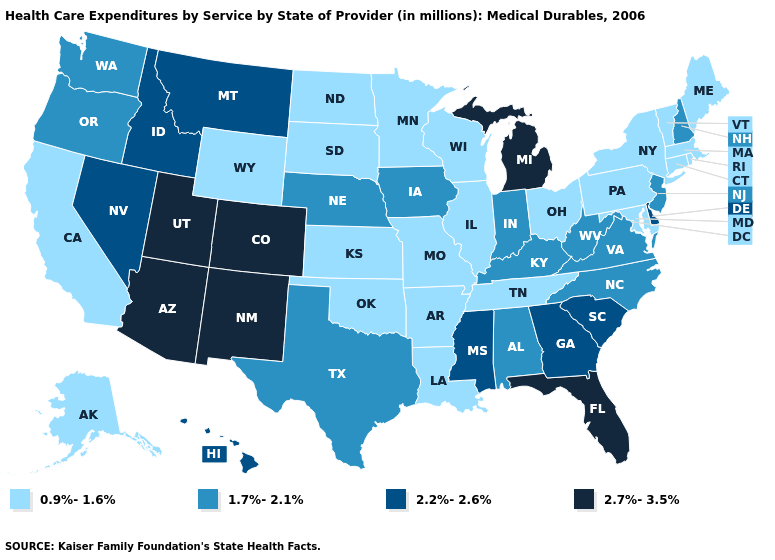Name the states that have a value in the range 1.7%-2.1%?
Give a very brief answer. Alabama, Indiana, Iowa, Kentucky, Nebraska, New Hampshire, New Jersey, North Carolina, Oregon, Texas, Virginia, Washington, West Virginia. What is the lowest value in states that border Texas?
Be succinct. 0.9%-1.6%. Name the states that have a value in the range 0.9%-1.6%?
Be succinct. Alaska, Arkansas, California, Connecticut, Illinois, Kansas, Louisiana, Maine, Maryland, Massachusetts, Minnesota, Missouri, New York, North Dakota, Ohio, Oklahoma, Pennsylvania, Rhode Island, South Dakota, Tennessee, Vermont, Wisconsin, Wyoming. Name the states that have a value in the range 0.9%-1.6%?
Be succinct. Alaska, Arkansas, California, Connecticut, Illinois, Kansas, Louisiana, Maine, Maryland, Massachusetts, Minnesota, Missouri, New York, North Dakota, Ohio, Oklahoma, Pennsylvania, Rhode Island, South Dakota, Tennessee, Vermont, Wisconsin, Wyoming. What is the value of West Virginia?
Concise answer only. 1.7%-2.1%. What is the lowest value in the USA?
Concise answer only. 0.9%-1.6%. Among the states that border Florida , which have the highest value?
Give a very brief answer. Georgia. What is the lowest value in the USA?
Short answer required. 0.9%-1.6%. Does Utah have the highest value in the USA?
Short answer required. Yes. Name the states that have a value in the range 0.9%-1.6%?
Quick response, please. Alaska, Arkansas, California, Connecticut, Illinois, Kansas, Louisiana, Maine, Maryland, Massachusetts, Minnesota, Missouri, New York, North Dakota, Ohio, Oklahoma, Pennsylvania, Rhode Island, South Dakota, Tennessee, Vermont, Wisconsin, Wyoming. What is the highest value in states that border Delaware?
Write a very short answer. 1.7%-2.1%. Does New Mexico have a lower value than Kansas?
Short answer required. No. What is the lowest value in the South?
Answer briefly. 0.9%-1.6%. What is the lowest value in the Northeast?
Be succinct. 0.9%-1.6%. Among the states that border Washington , which have the highest value?
Quick response, please. Idaho. 